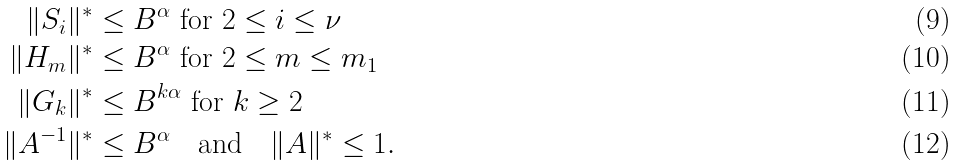Convert formula to latex. <formula><loc_0><loc_0><loc_500><loc_500>\| S _ { i } \| ^ { * } & \leq B ^ { \alpha } \ \text {for $2\leq i\leq\nu$} \\ \| H _ { m } \| ^ { * } & \leq B ^ { \alpha } \ \text {for $2\leq m\leq m_{1}$} \\ \| G _ { k } \| ^ { * } & \leq B ^ { k \alpha } \ \text {for $k\geq 2$} \\ \| A ^ { - 1 } \| ^ { * } & \leq B ^ { \alpha } \quad \text {and} \quad \| A \| ^ { * } \leq 1 .</formula> 